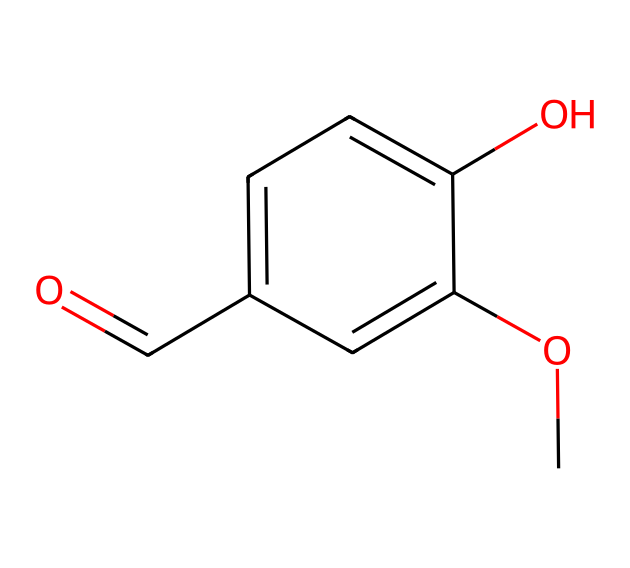What is the molecular formula of this compound? To determine the molecular formula, count the number of each type of atom in the SMILES representation. The structure shows 9 carbon atoms (C), 10 hydrogen atoms (H), 3 oxygen atoms (O). Thus, the molecular formula is C9H10O3.
Answer: C9H10O3 How many functional groups are present in this compound? Analyzing the SMILES shows one hydroxyl group (-OH) and one methoxy group (-OCH3), indicating the presence of two functional groups. Therefore, there are two functional groups.
Answer: 2 What type of compound is this? The presence of a hydroxyl group indicates this is an aromatic compound with alcohol functionality, classifying it as an aromatic alcohol.
Answer: aromatic alcohol Which aromatic system is present in this chemical? By examining the structure, it contains a benzene ring, which is a characteristic aromatic system. Therefore, the aromatic system is a benzene ring.
Answer: benzene What is the characteristic smell associated with this chemical? Compounds responsible for the 'new book smell' often involve volatile organic compounds, hence this compound may contribute with its aromatic properties and ester functionalities, which generally emit characteristic pleasant odors.
Answer: pleasant odors 